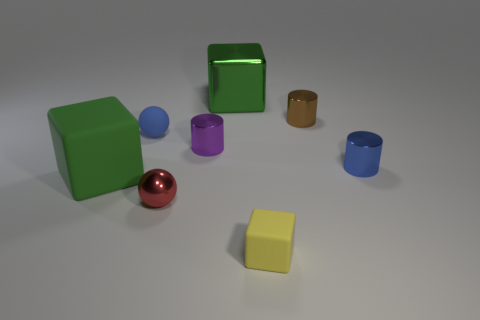Subtract all small brown cylinders. How many cylinders are left? 2 Add 2 tiny brown metal things. How many objects exist? 10 Subtract all spheres. How many objects are left? 6 Subtract all objects. Subtract all cyan shiny cylinders. How many objects are left? 0 Add 2 blue rubber spheres. How many blue rubber spheres are left? 3 Add 6 yellow rubber spheres. How many yellow rubber spheres exist? 6 Subtract all blue cylinders. How many cylinders are left? 2 Subtract 0 red blocks. How many objects are left? 8 Subtract 2 cylinders. How many cylinders are left? 1 Subtract all green cylinders. Subtract all cyan blocks. How many cylinders are left? 3 